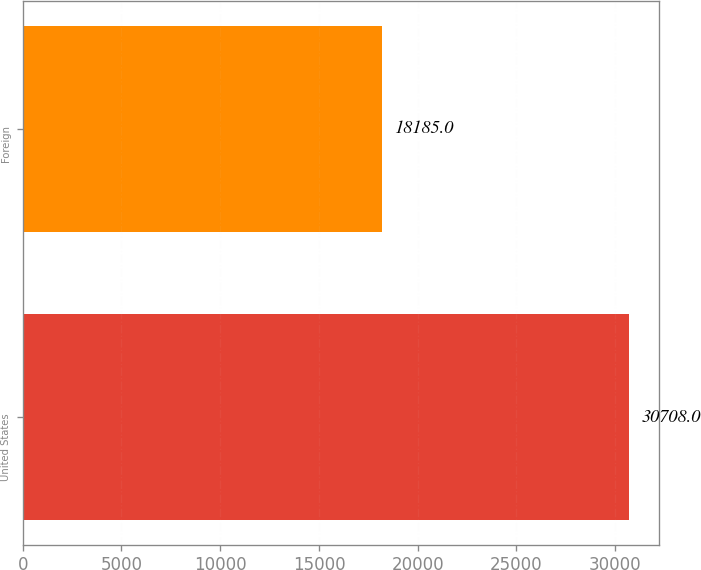Convert chart. <chart><loc_0><loc_0><loc_500><loc_500><bar_chart><fcel>United States<fcel>Foreign<nl><fcel>30708<fcel>18185<nl></chart> 